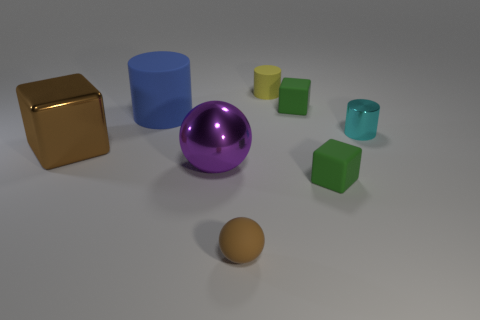Does the tiny rubber ball have the same color as the big cube?
Your response must be concise. Yes. Are there any tiny yellow rubber cylinders?
Provide a succinct answer. Yes. Are the green cube that is behind the large cylinder and the large thing that is behind the small shiny object made of the same material?
Your answer should be very brief. Yes. There is a thing that is the same color as the small matte ball; what is its shape?
Make the answer very short. Cube. How many things are things that are behind the brown metallic thing or things that are on the left side of the small yellow cylinder?
Keep it short and to the point. 7. There is a cube that is behind the large cylinder; does it have the same color as the matte cube that is in front of the metal ball?
Give a very brief answer. Yes. There is a shiny thing that is behind the purple object and on the right side of the big blue cylinder; what shape is it?
Ensure brevity in your answer.  Cylinder. The matte cylinder that is the same size as the cyan metal object is what color?
Provide a short and direct response. Yellow. Are there any small balls of the same color as the big metallic cube?
Give a very brief answer. Yes. There is a cube that is to the left of the small matte cylinder; is it the same size as the metal object that is on the right side of the tiny yellow matte cylinder?
Your answer should be very brief. No. 